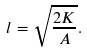Convert formula to latex. <formula><loc_0><loc_0><loc_500><loc_500>l = \sqrt { \frac { 2 K } { A } } .</formula> 